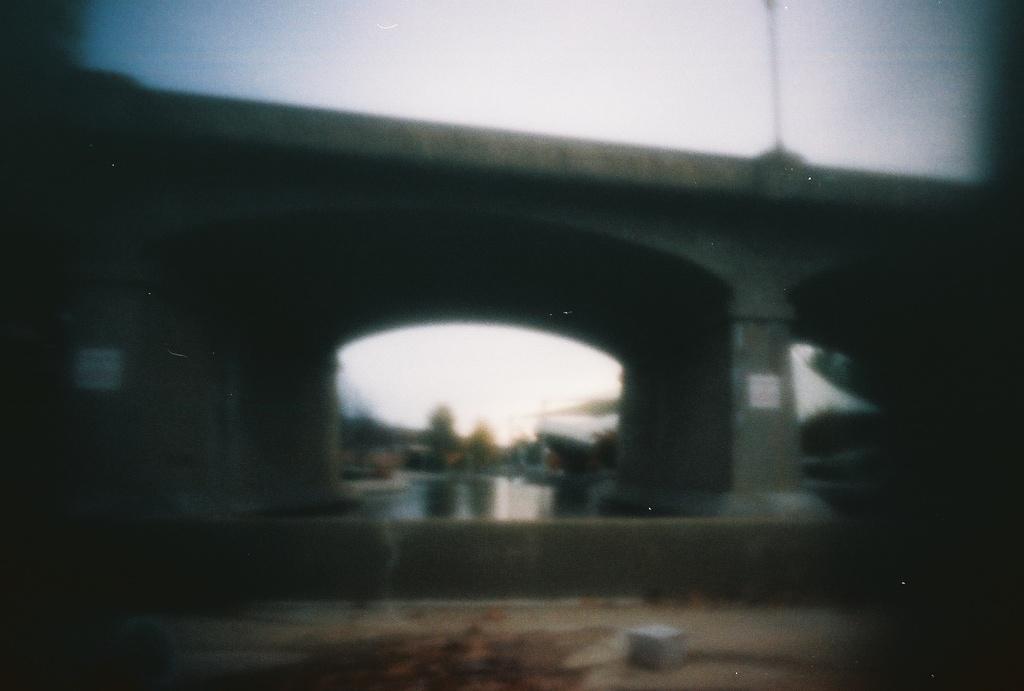Describe this image in one or two sentences. This is a bridge, this is water and a sky. 